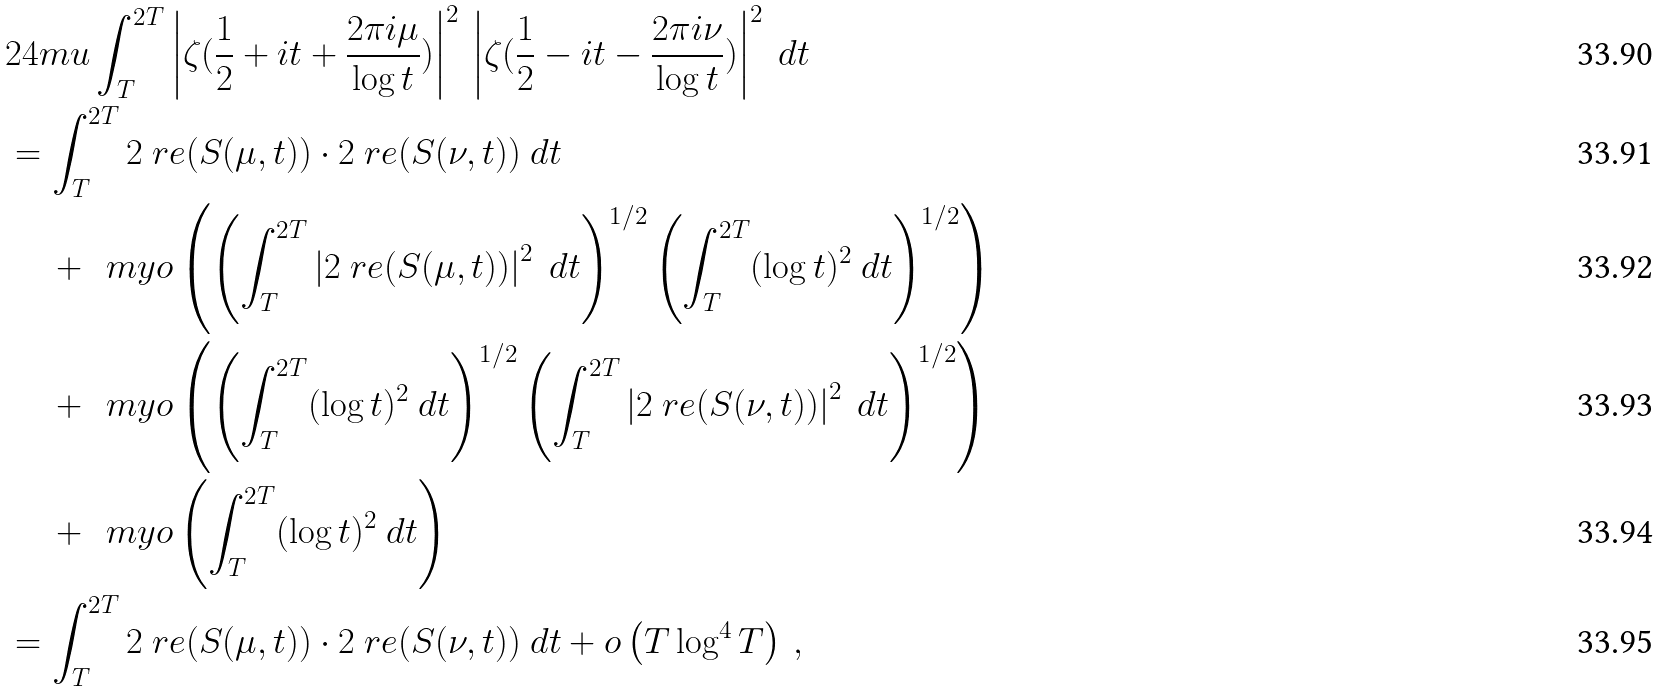Convert formula to latex. <formula><loc_0><loc_0><loc_500><loc_500>& 2 4 m u \int _ { T } ^ { 2 T } \left | \zeta ( \frac { 1 } { 2 } + i t + \frac { 2 \pi i \mu } { \log t } ) \right | ^ { 2 } \, \left | \zeta ( \frac { 1 } { 2 } - i t - \frac { 2 \pi i \nu } { \log t } ) \right | ^ { 2 } \ d t \\ & = \int _ { T } ^ { 2 T } 2 \ r e ( S ( \mu , t ) ) \cdot 2 \ r e ( S ( \nu , t ) ) \ d t \\ & \quad \, + \, \ m y o \left ( \left ( \int _ { T } ^ { 2 T } \left | 2 \ r e ( S ( \mu , t ) ) \right | ^ { 2 } \ d t \right ) ^ { 1 / 2 } \left ( \int _ { T } ^ { 2 T } ( \log t ) ^ { 2 } \ d t \right ) ^ { 1 / 2 } \right ) \\ & \quad \, + \, \ m y o \left ( \left ( \int _ { T } ^ { 2 T } ( \log t ) ^ { 2 } \ d t \right ) ^ { 1 / 2 } \left ( \int _ { T } ^ { 2 T } \left | 2 \ r e ( S ( \nu , t ) ) \right | ^ { 2 } \ d t \right ) ^ { 1 / 2 } \right ) \\ & \quad \, + \, \ m y o \left ( \int _ { T } ^ { 2 T } ( \log t ) ^ { 2 } \ d t \right ) \\ & = \int _ { T } ^ { 2 T } 2 \ r e ( S ( \mu , t ) ) \cdot 2 \ r e ( S ( \nu , t ) ) \ d t + o \left ( T \log ^ { 4 } T \right ) \, ,</formula> 